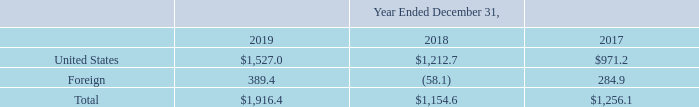AMERICAN TOWER CORPORATION AND SUBSIDIARIES NOTES TO CONSOLIDATED FINANCIAL STATEMENTS (Tabular amounts in millions, unless otherwise disclosed)
The domestic and foreign components of income from continuing operations before income taxes are as follows:
What was the income from continuing operations before income taxes from United States in 2019?
Answer scale should be: million. $1,527.0. What was the income from continuing operations before income taxes from Foreign sources in 2018?
Answer scale should be: million. (58.1). What was the total income from continuing operations before income taxes in 2018?
Answer scale should be: million. $1,154.6. How many years did income from continuing operations before income taxes from the United States exceed $1,000 million? 2019##2018
Answer: 2. How many years did total income from continuing operations before income taxes exceed $1,000 million? 2019##2018##2017
Answer: 3. What was the percentage change in total income from continuing operations before income taxes between 2018 and 2019?
Answer scale should be: percent. ($1,916.4-$1,154.6)/$1,154.6
Answer: 65.98. 